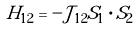<formula> <loc_0><loc_0><loc_500><loc_500>H _ { 1 2 } = - \mathcal { J } _ { 1 2 } S _ { 1 } \cdot S _ { 2 }</formula> 